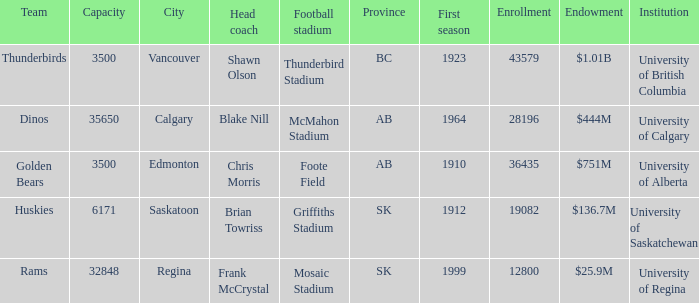What year did University of Saskatchewan have their first season? 1912.0. Could you parse the entire table as a dict? {'header': ['Team', 'Capacity', 'City', 'Head coach', 'Football stadium', 'Province', 'First season', 'Enrollment', 'Endowment', 'Institution'], 'rows': [['Thunderbirds', '3500', 'Vancouver', 'Shawn Olson', 'Thunderbird Stadium', 'BC', '1923', '43579', '$1.01B', 'University of British Columbia'], ['Dinos', '35650', 'Calgary', 'Blake Nill', 'McMahon Stadium', 'AB', '1964', '28196', '$444M', 'University of Calgary'], ['Golden Bears', '3500', 'Edmonton', 'Chris Morris', 'Foote Field', 'AB', '1910', '36435', '$751M', 'University of Alberta'], ['Huskies', '6171', 'Saskatoon', 'Brian Towriss', 'Griffiths Stadium', 'SK', '1912', '19082', '$136.7M', 'University of Saskatchewan'], ['Rams', '32848', 'Regina', 'Frank McCrystal', 'Mosaic Stadium', 'SK', '1999', '12800', '$25.9M', 'University of Regina']]} 